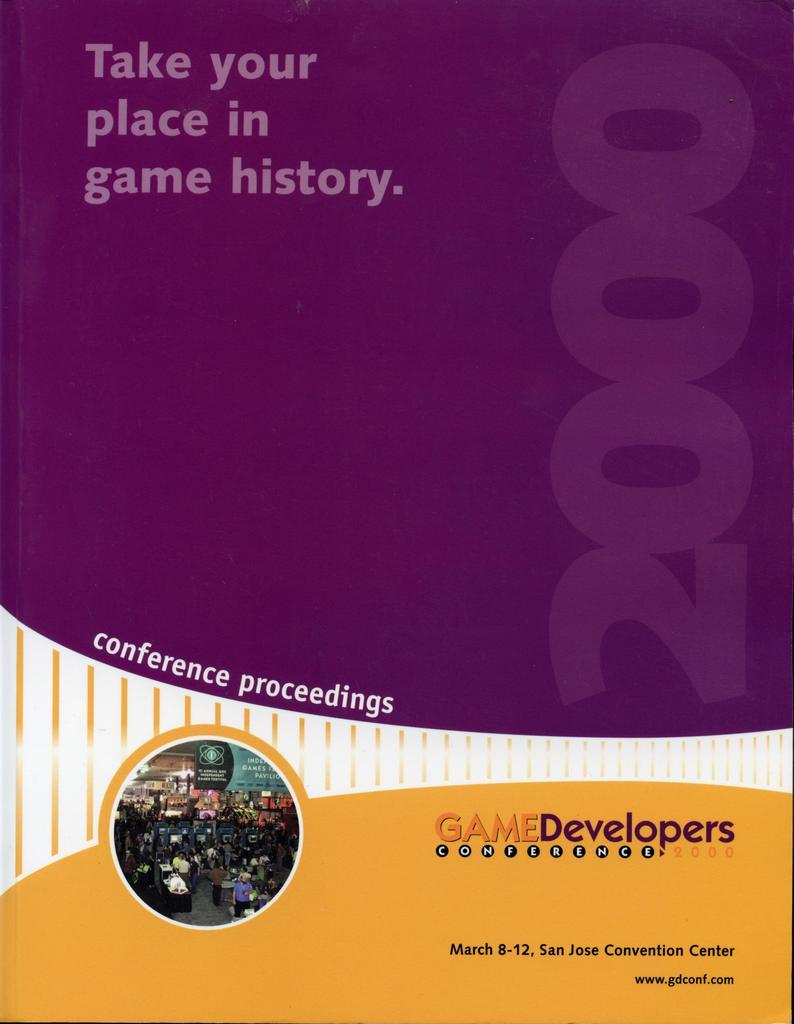Where is the convention being held?
Your answer should be very brief. San jose convention center. Who is speaking at the conference?
Your answer should be compact. Game developers. 